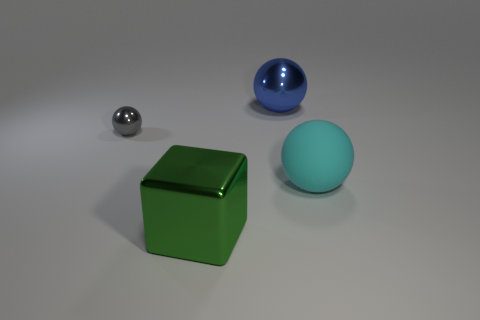Subtract all big shiny balls. How many balls are left? 2 Add 3 tiny yellow rubber things. How many objects exist? 7 Subtract all balls. How many objects are left? 1 Subtract 2 balls. How many balls are left? 1 Subtract all green cubes. Subtract all tiny gray metallic spheres. How many objects are left? 2 Add 4 cyan rubber things. How many cyan rubber things are left? 5 Add 1 red cubes. How many red cubes exist? 1 Subtract 0 gray blocks. How many objects are left? 4 Subtract all yellow balls. Subtract all blue cylinders. How many balls are left? 3 